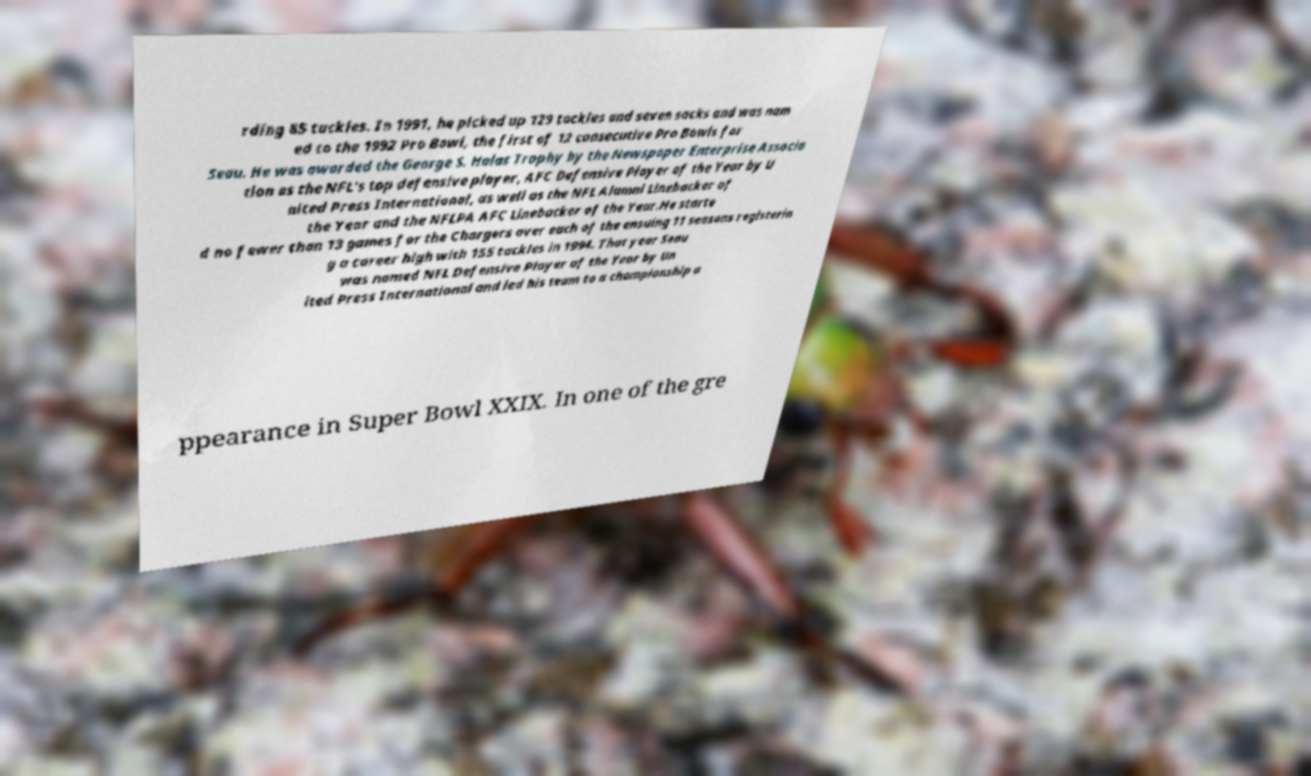Can you accurately transcribe the text from the provided image for me? rding 85 tackles. In 1991, he picked up 129 tackles and seven sacks and was nam ed to the 1992 Pro Bowl, the first of 12 consecutive Pro Bowls for Seau. He was awarded the George S. Halas Trophy by the Newspaper Enterprise Associa tion as the NFL's top defensive player, AFC Defensive Player of the Year by U nited Press International, as well as the NFL Alumni Linebacker of the Year and the NFLPA AFC Linebacker of the Year.He starte d no fewer than 13 games for the Chargers over each of the ensuing 11 seasons registerin g a career high with 155 tackles in 1994. That year Seau was named NFL Defensive Player of the Year by Un ited Press International and led his team to a championship a ppearance in Super Bowl XXIX. In one of the gre 